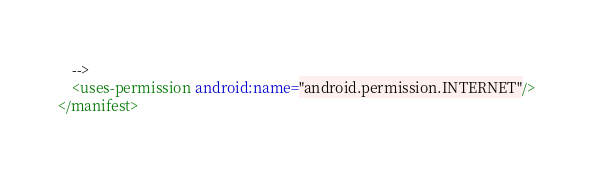Convert code to text. <code><loc_0><loc_0><loc_500><loc_500><_XML_>    -->
    <uses-permission android:name="android.permission.INTERNET"/>
</manifest>
</code> 